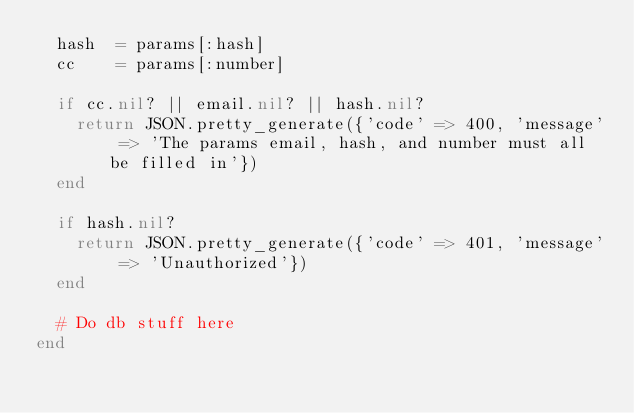<code> <loc_0><loc_0><loc_500><loc_500><_Ruby_>  hash  = params[:hash]
  cc    = params[:number]

  if cc.nil? || email.nil? || hash.nil?
    return JSON.pretty_generate({'code' => 400, 'message' => 'The params email, hash, and number must all be filled in'})
  end

  if hash.nil?
    return JSON.pretty_generate({'code' => 401, 'message' => 'Unauthorized'})
  end

  # Do db stuff here
end
</code> 